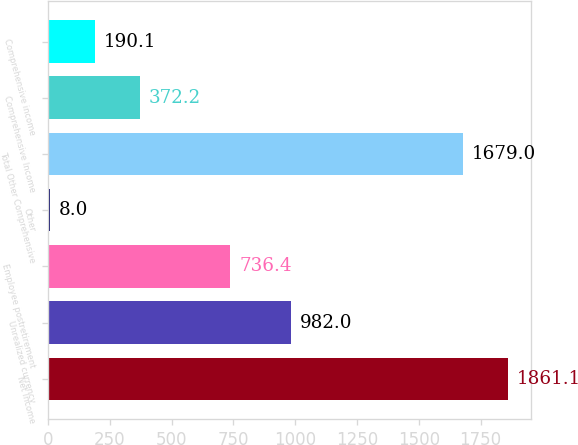<chart> <loc_0><loc_0><loc_500><loc_500><bar_chart><fcel>Net Income<fcel>Unrealized currency<fcel>Employee postretirement<fcel>Other<fcel>Total Other Comprehensive<fcel>Comprehensive Income<fcel>Comprehensive income<nl><fcel>1861.1<fcel>982<fcel>736.4<fcel>8<fcel>1679<fcel>372.2<fcel>190.1<nl></chart> 